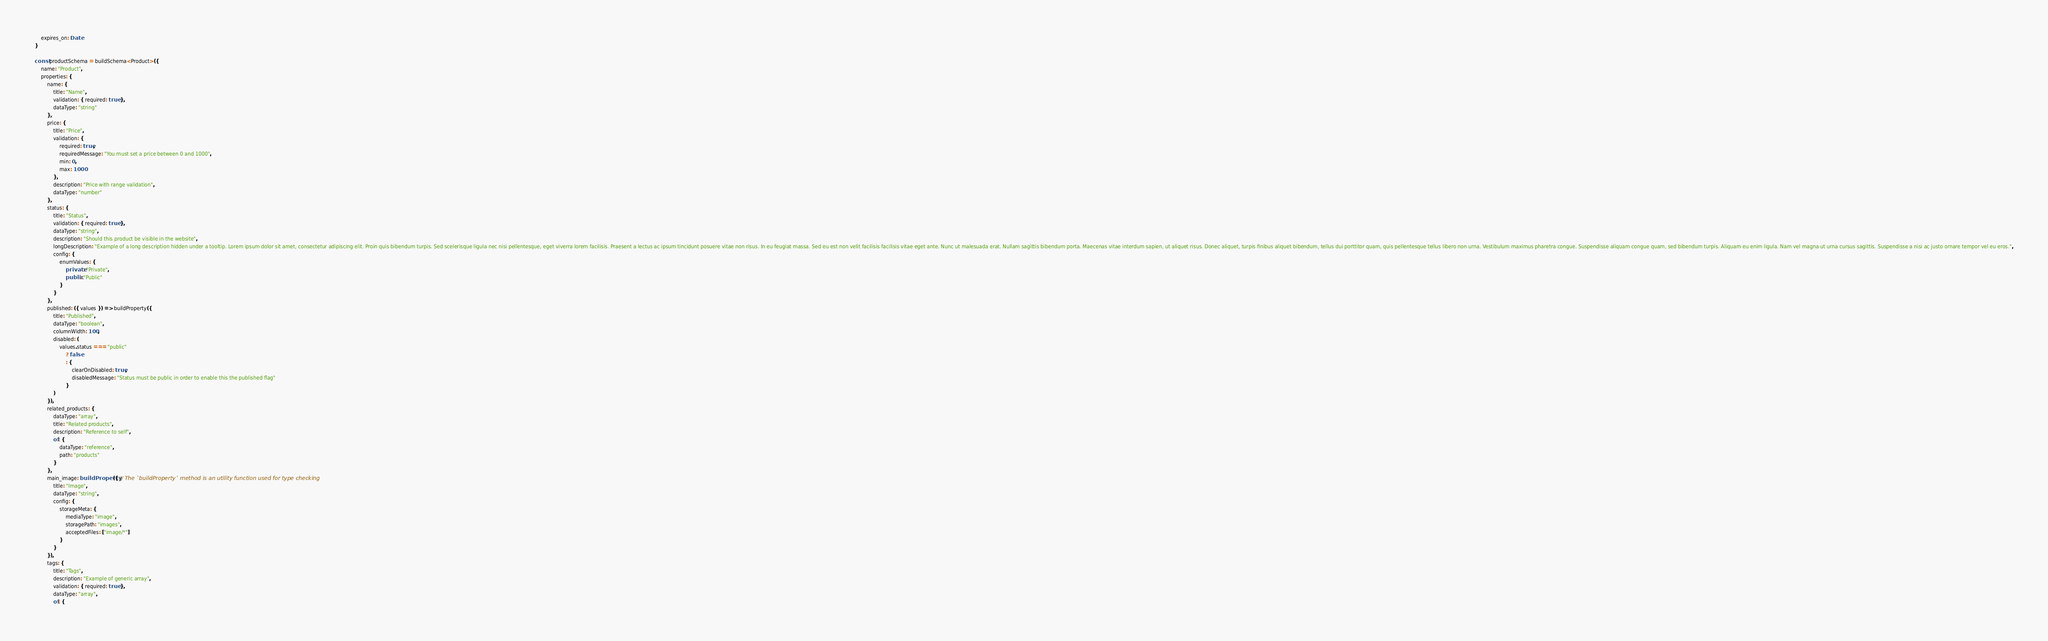<code> <loc_0><loc_0><loc_500><loc_500><_TypeScript_>    expires_on: Date
}

const productSchema = buildSchema<Product>({
    name: "Product",
    properties: {
        name: {
            title: "Name",
            validation: { required: true },
            dataType: "string"
        },
        price: {
            title: "Price",
            validation: {
                required: true,
                requiredMessage: "You must set a price between 0 and 1000",
                min: 0,
                max: 1000
            },
            description: "Price with range validation",
            dataType: "number"
        },
        status: {
            title: "Status",
            validation: { required: true },
            dataType: "string",
            description: "Should this product be visible in the website",
            longDescription: "Example of a long description hidden under a tooltip. Lorem ipsum dolor sit amet, consectetur adipiscing elit. Proin quis bibendum turpis. Sed scelerisque ligula nec nisi pellentesque, eget viverra lorem facilisis. Praesent a lectus ac ipsum tincidunt posuere vitae non risus. In eu feugiat massa. Sed eu est non velit facilisis facilisis vitae eget ante. Nunc ut malesuada erat. Nullam sagittis bibendum porta. Maecenas vitae interdum sapien, ut aliquet risus. Donec aliquet, turpis finibus aliquet bibendum, tellus dui porttitor quam, quis pellentesque tellus libero non urna. Vestibulum maximus pharetra congue. Suspendisse aliquam congue quam, sed bibendum turpis. Aliquam eu enim ligula. Nam vel magna ut urna cursus sagittis. Suspendisse a nisi ac justo ornare tempor vel eu eros.",
            config: {
                enumValues: {
                    private: "Private",
                    public: "Public"
                }
            }
        },
        published: ({ values }) => buildProperty({
            title: "Published",
            dataType: "boolean",
            columnWidth: 100,
            disabled: (
                values.status === "public"
                    ? false
                    : {
                        clearOnDisabled: true,
                        disabledMessage: "Status must be public in order to enable this the published flag"
                    }
            )
        }),
        related_products: {
            dataType: "array",
            title: "Related products",
            description: "Reference to self",
            of: {
                dataType: "reference",
                path: "products"
            }
        },
        main_image: buildProperty({ // The `buildProperty` method is an utility function used for type checking
            title: "Image",
            dataType: "string",
            config: {
                storageMeta: {
                    mediaType: "image",
                    storagePath: "images",
                    acceptedFiles: ["image/*"]
                }
            }
        }),
        tags: {
            title: "Tags",
            description: "Example of generic array",
            validation: { required: true },
            dataType: "array",
            of: {</code> 